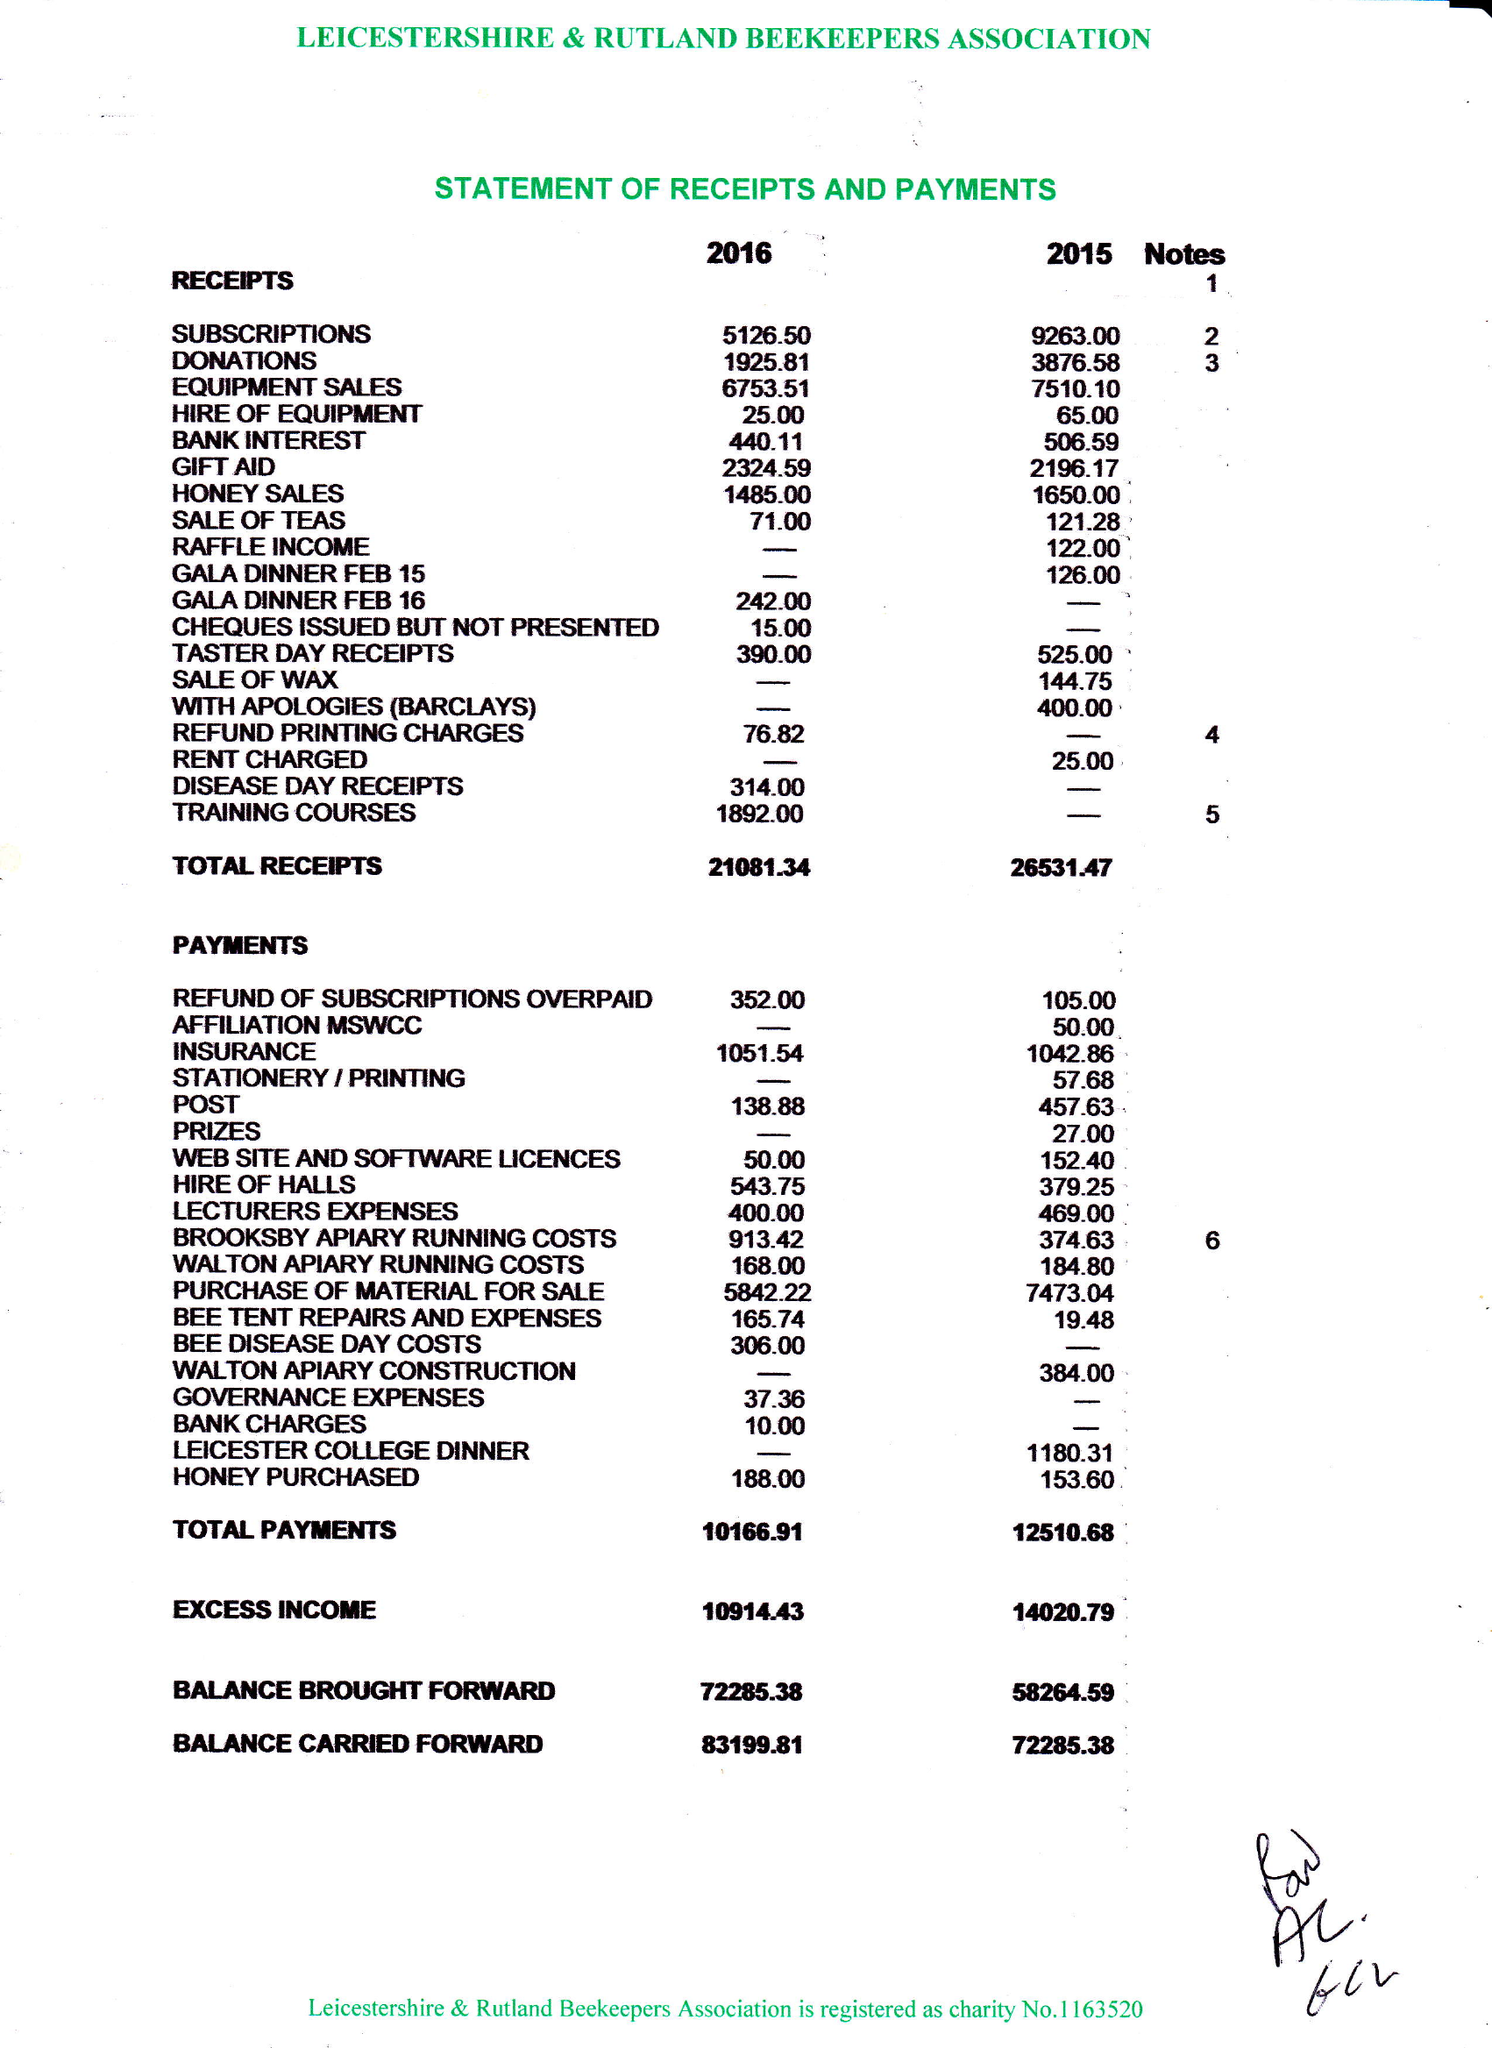What is the value for the address__post_town?
Answer the question using a single word or phrase. LUTTERWORTH 